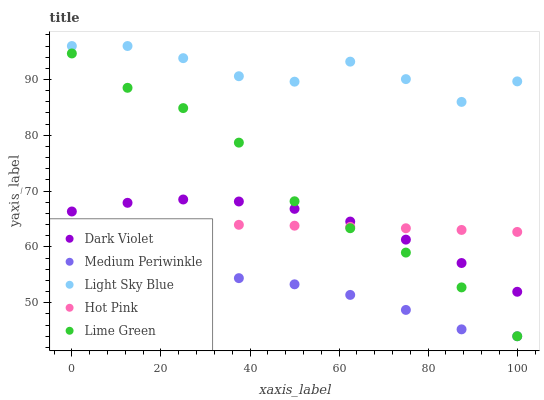Does Medium Periwinkle have the minimum area under the curve?
Answer yes or no. Yes. Does Light Sky Blue have the maximum area under the curve?
Answer yes or no. Yes. Does Light Sky Blue have the minimum area under the curve?
Answer yes or no. No. Does Medium Periwinkle have the maximum area under the curve?
Answer yes or no. No. Is Hot Pink the smoothest?
Answer yes or no. Yes. Is Light Sky Blue the roughest?
Answer yes or no. Yes. Is Medium Periwinkle the smoothest?
Answer yes or no. No. Is Medium Periwinkle the roughest?
Answer yes or no. No. Does Lime Green have the lowest value?
Answer yes or no. Yes. Does Light Sky Blue have the lowest value?
Answer yes or no. No. Does Light Sky Blue have the highest value?
Answer yes or no. Yes. Does Medium Periwinkle have the highest value?
Answer yes or no. No. Is Hot Pink less than Light Sky Blue?
Answer yes or no. Yes. Is Light Sky Blue greater than Dark Violet?
Answer yes or no. Yes. Does Hot Pink intersect Lime Green?
Answer yes or no. Yes. Is Hot Pink less than Lime Green?
Answer yes or no. No. Is Hot Pink greater than Lime Green?
Answer yes or no. No. Does Hot Pink intersect Light Sky Blue?
Answer yes or no. No. 